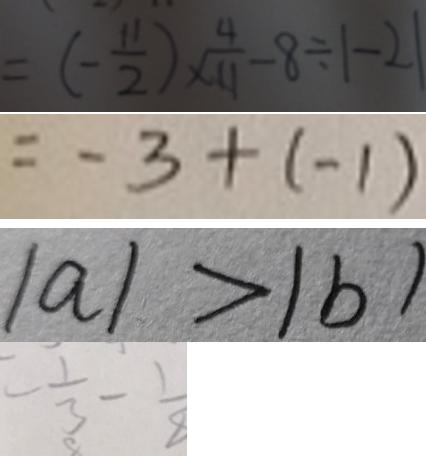Convert formula to latex. <formula><loc_0><loc_0><loc_500><loc_500>= ( - \frac { 1 1 } { 2 } ) \times \frac { 4 } { 1 1 } - 8 \div \vert - 2 \vert 
 = - 3 + ( - 1 ) 
 \vert a \vert > \vert b \vert 
 = \frac { 1 } { 3 } - \frac { 1 } { 8 }</formula> 